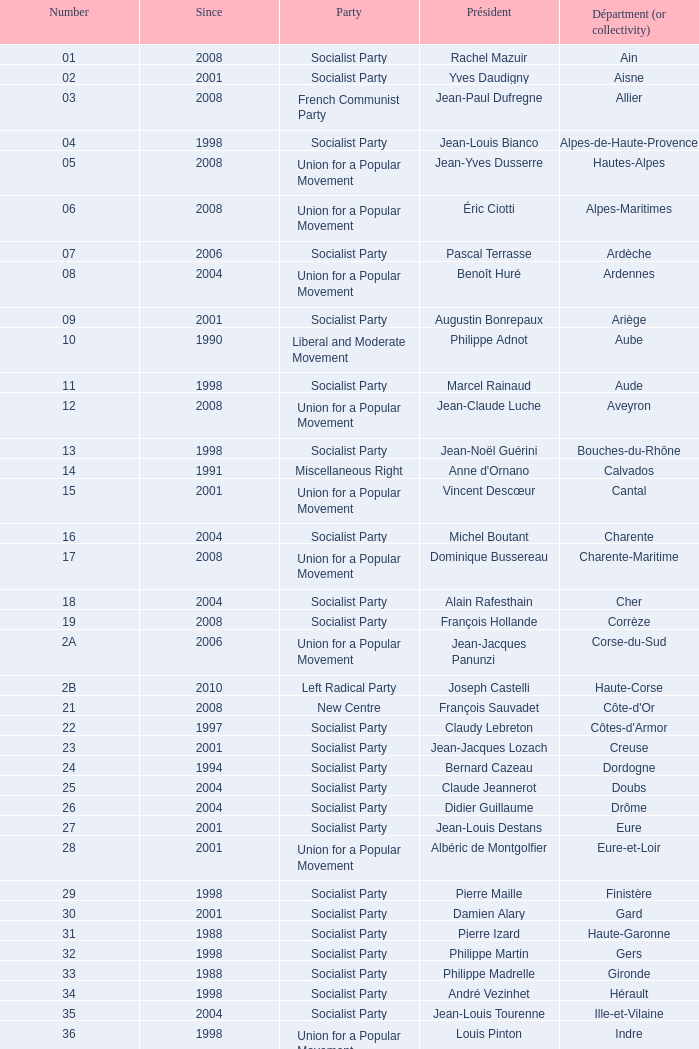Who is the president representing the Creuse department? Jean-Jacques Lozach. 